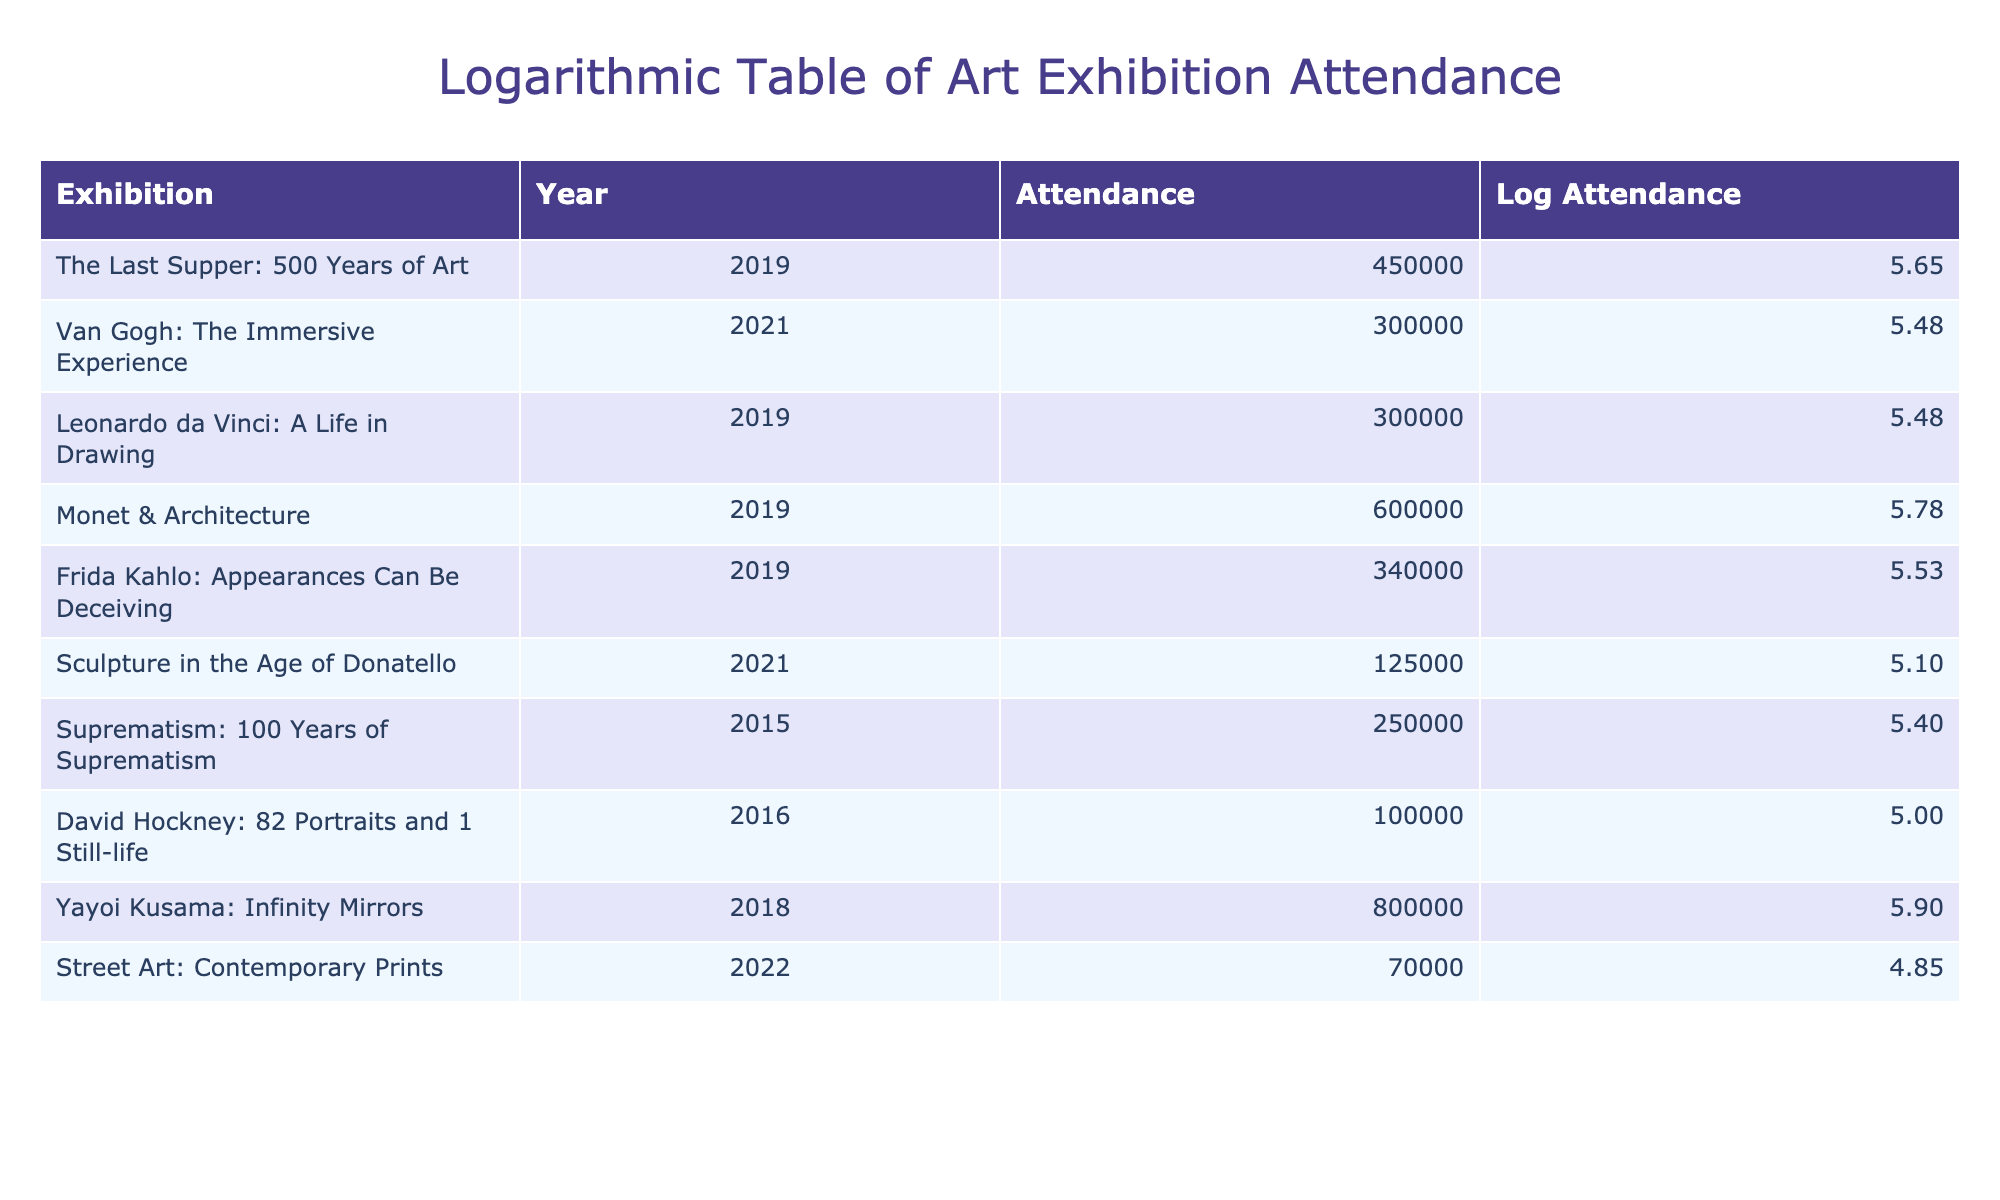What was the attendance for "Yayoi Kusama: Infinity Mirrors"? The table lists "Yayoi Kusama: Infinity Mirrors" with an attendance of 800000.
Answer: 800000 Which exhibition had the lowest attendance? The table indicates that "Street Art: Contemporary Prints," with an attendance of 70000, had the lowest figure among all listed exhibitions.
Answer: 70000 What is the total attendance for exhibitions held in 2019? The exhibitions from 2019 include "The Last Supper: 500 Years of Art" (450000), "Leonardo da Vinci: A Life in Drawing" (300000), "Monet & Architecture" (600000), and "Frida Kahlo: Appearances Can Be Deceiving" (340000). Adding these values gives a total of 450000 + 300000 + 600000 + 340000 = 1690000.
Answer: 1690000 Is it true that "Sculpture in the Age of Donatello" had an attendance greater than 100000? The table shows "Sculpture in the Age of Donatello" with an attendance of 125000, which is greater than 100000. Thus, the statement is true.
Answer: Yes What is the difference in attendance between the most attended exhibition and the least attended exhibition? The most attended exhibition is "Yayoi Kusama: Infinity Mirrors" (800000) and the least attended is "Street Art: Contemporary Prints" (70000). The difference is calculated as 800000 - 70000 = 730000.
Answer: 730000 What are the average attendance figures for exhibitions held in 2021? The exhibitions held in 2021 are "Van Gogh: The Immersive Experience" (300000) and "Sculpture in the Age of Donatello" (125000). The average is calculated as (300000 + 125000) / 2 = 212500.
Answer: 212500 Which exhibition took place in 2022 and what was its attendance? According to the table, "Street Art: Contemporary Prints" took place in 2022 with an attendance of 70000.
Answer: 70000 Was the attendance for "Frida Kahlo: Appearances Can Be Deceiving" higher than "Van Gogh: The Immersive Experience"? "Frida Kahlo: Appearances Can Be Deceiving" had an attendance of 340000, while "Van Gogh: The Immersive Experience" had 300000. Since 340000 is greater than 300000, the statement is true.
Answer: Yes What is the total attendance for exhibitions from 2015 to 2021? The relevant exhibitions are "Suprematism: 100 Years of Suprematism" (250000, 2015), "David Hockney: 82 Portraits and 1 Still-life" (100000, 2016), "Van Gogh: The Immersive Experience" (300000, 2021), and "Sculpture in the Age of Donatello" (125000, 2021). Adding these figures gives 250000 + 100000 + 300000 + 125000 = 775000.
Answer: 775000 